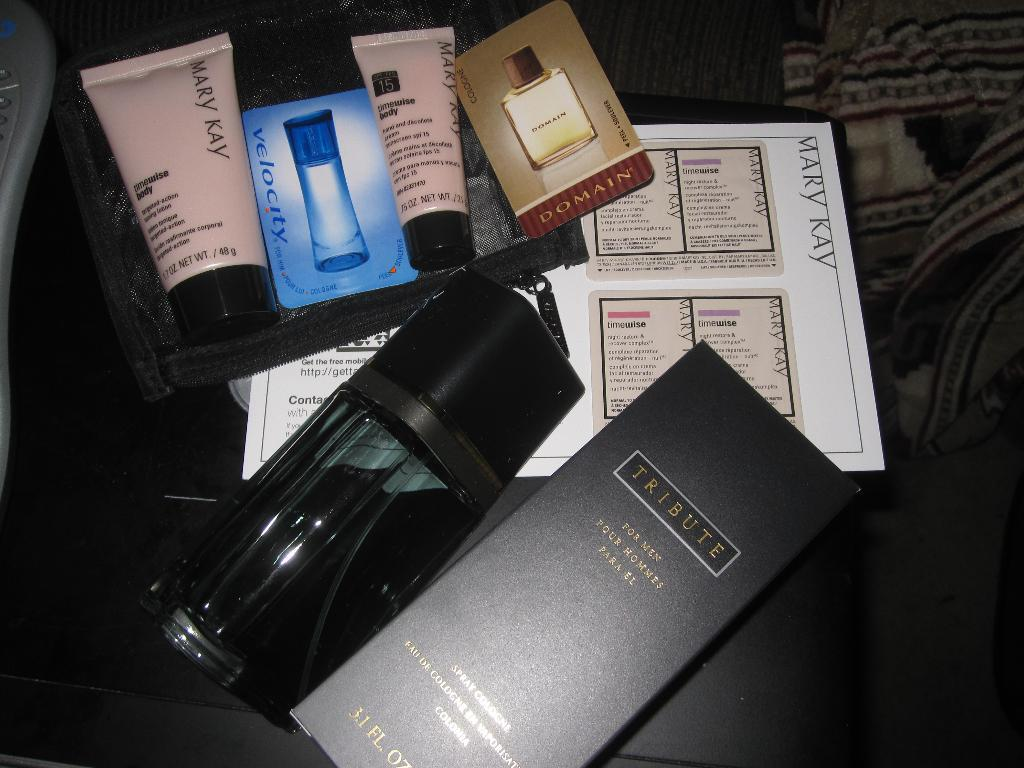<image>
Share a concise interpretation of the image provided. Box with a Tribute label and a Mary Kay logo on a pink bottle. 